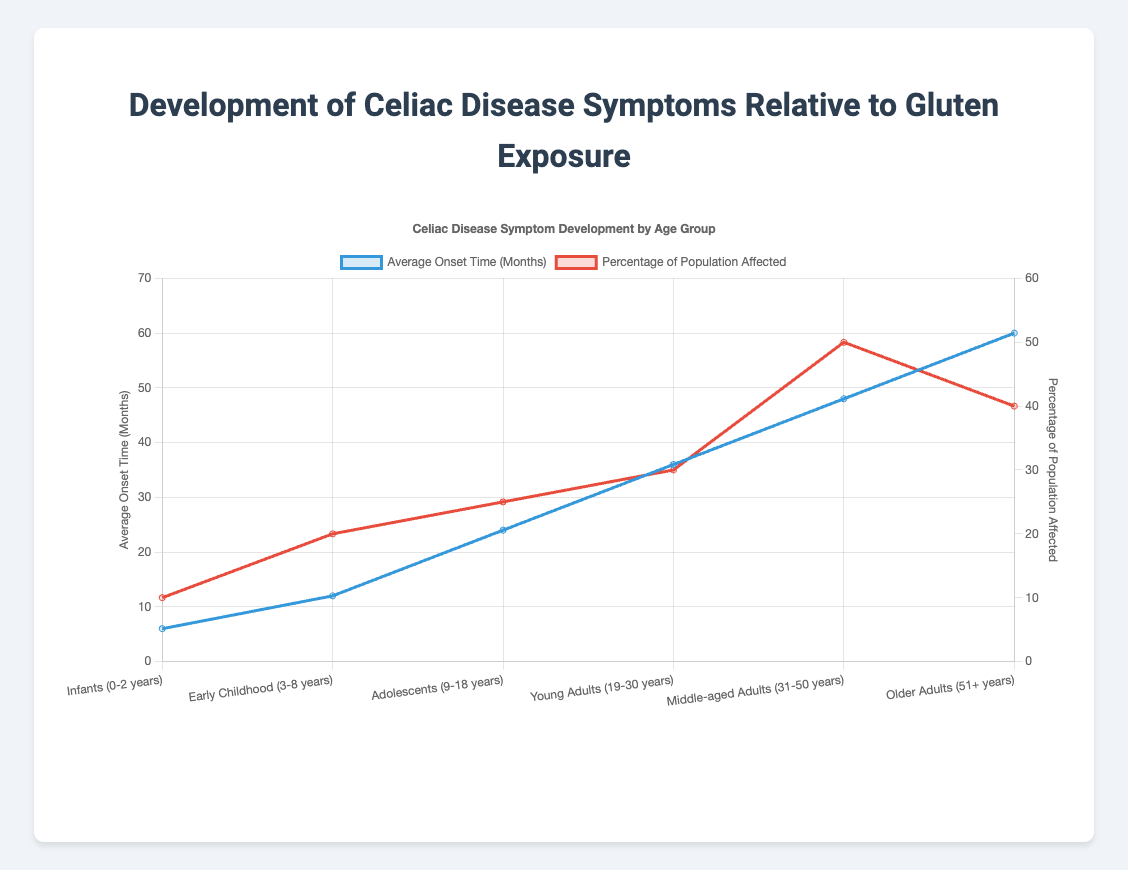What is the average onset time of Celiac Disease symptoms for Adolescents? The Adolescents age group (9-18 years) has an average onset time of 24 months as indicated by the dataset.
Answer: 24 months Which age group has the highest percentage of the population affected by Celiac Disease? Middle-aged Adults (31-50 years) have the highest percentage of the population affected at 50%, as indicated by the red line reaching its peak.
Answer: Middle-aged Adults (31-50 years) What is the sum of the average onset times for Infants and Early Childhood groups? The average onset time for Infants (0-2 years) is 6 months, and for Early Childhood (3-8 years) it is 12 months. The sum is 6 + 12 = 18 months.
Answer: 18 months How does the percentage of the population affected in Young Adults compare to Older Adults? The percentage of the population affected in Young Adults (19-30 years) is 30%, while in Older Adults (51+ years) it is 40%, so Young Adults are affected 10% less than Older Adults.
Answer: 10% less Which age group has the common symptoms including Osteopenia/Osteoporosis? The common symptoms listed for Middle-aged Adults (31-50 years) include Osteopenia/Osteoporosis.
Answer: Middle-aged Adults (31-50 years) What is the average of the percentages of the population affected for the first three age groups? The percentages are 10% (Infants), 20% (Early Childhood), and 25% (Adolescents). The average is (10 + 20 + 25) / 3 = 18.33%.
Answer: 18.33% Which group has a lower average onset time: Early Childhood or Adolescents? Early Childhood (3-8 years) has an average onset time of 12 months, and Adolescents (9-18 years) have 24 months. Early Childhood has a lower onset time.
Answer: Early Childhood (3-8 years) What is the difference between the average onset time of Young Adults and Middle-aged Adults? Young Adults (19-30 years) have an average onset time of 36 months while Middle-aged Adults (31-50 years) have 48 months. The difference is 48 - 36 = 12 months.
Answer: 12 months Which common symptoms are found in the Adolescents age group? Adolescents (9-18 years) exhibit symptoms such as Delayed puberty, Abdominal pain, and Anemia.
Answer: Delayed puberty, Abdominal pain, Anemia Is the percentage of the population affected higher in Infants or Early Childhood? Infants (0-2 years) have 10% affected, while Early Childhood (3-8 years) has 20% affected. Thus, Early Childhood has a higher percentage.
Answer: Early Childhood (3-8 years) 